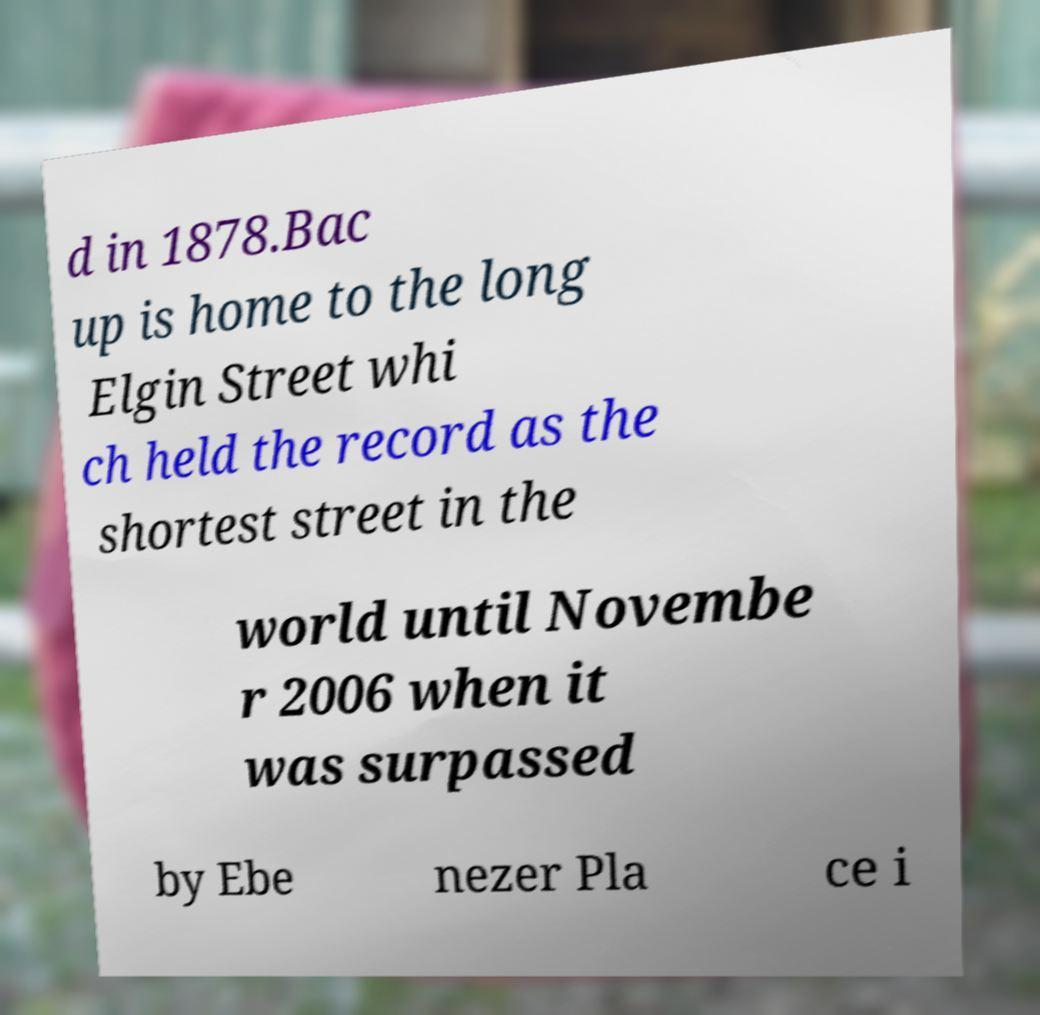Can you read and provide the text displayed in the image?This photo seems to have some interesting text. Can you extract and type it out for me? d in 1878.Bac up is home to the long Elgin Street whi ch held the record as the shortest street in the world until Novembe r 2006 when it was surpassed by Ebe nezer Pla ce i 